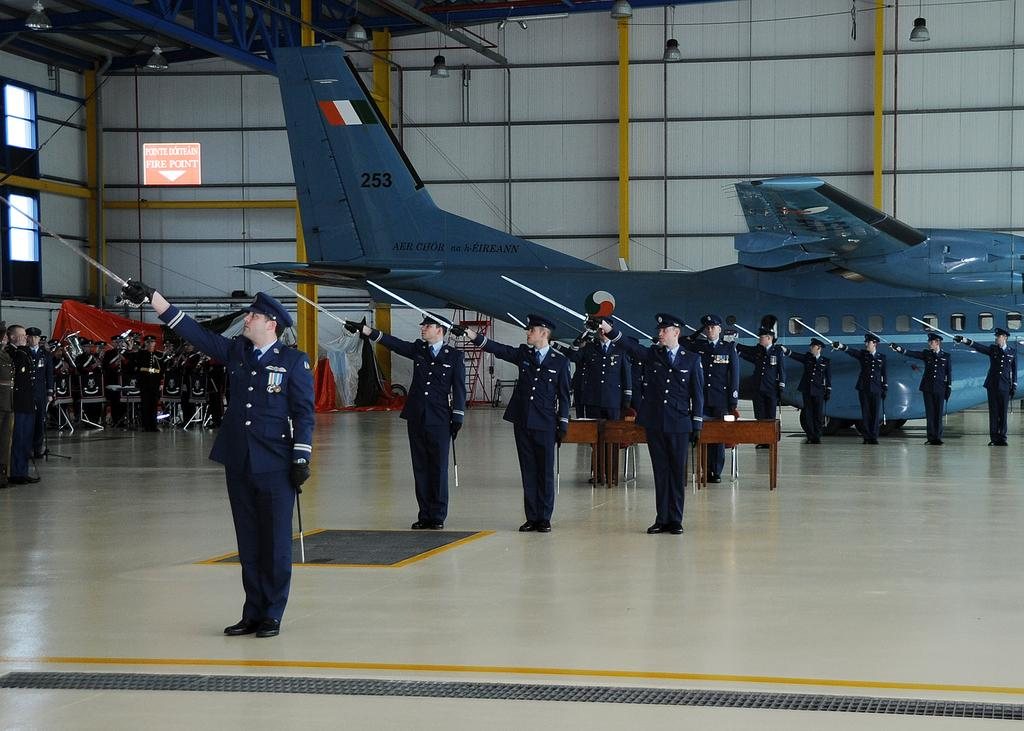Provide a one-sentence caption for the provided image. A few people stand in position i front of a plane with 253 on the tail. 